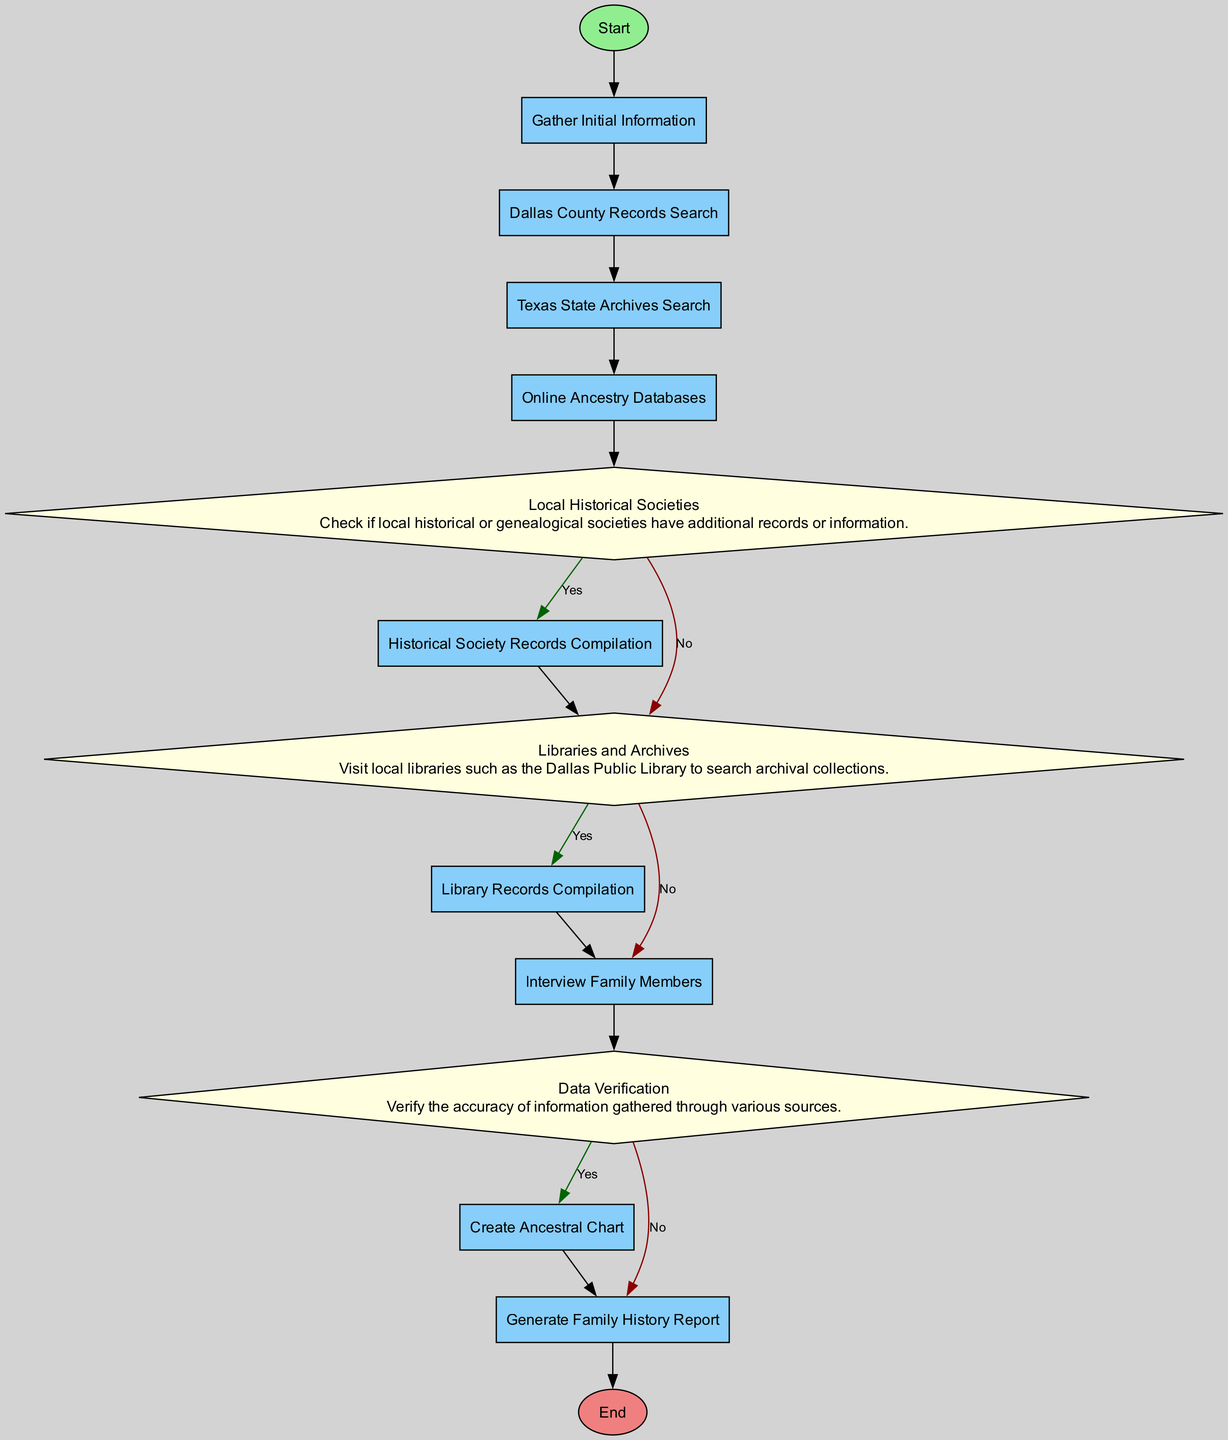What is the first step in the diagram? The diagram begins with the "Start" node, which signifies the initiation of the process. Therefore, the first step is simply to start the process.
Answer: Start How many decision nodes are present in the diagram? By reviewing the process flow, there are two decision nodes labeled "Local Historical Societies" and "Libraries and Archives." Thus, the total count of decision nodes is two.
Answer: 2 What follows the "Gather Initial Information" step? After the "Gather Initial Information," the next process in the flow is "Dallas County Records Search." This indicates a direct progression from gathering initial information to searching county records.
Answer: Dallas County Records Search What type of node is "Data Verification"? "Data Verification" is classified as a Decision node in the flowchart. This type of node indicates a point in the process where a yes/no decision must be made based on the information gathered.
Answer: Decision What process occurs after "Local Historical Societies"? Following the "Local Historical Societies" decision node, the flowchart leads to the process "Historical Society Records Compilation." This shows that if local societies have information, the next step is to compile it.
Answer: Historical Society Records Compilation How many processes are there in the diagram? The diagram consists of several process nodes, including "Gather Initial Information," "Dallas County Records Search," "Texas State Archives Search," "Online Ancestry Databases," "Historical Society Records Compilation," "Library Records Compilation," "Interview Family Members," "Create Ancestral Chart," and "Generate Family History Report." Counting these gives a total of nine process nodes.
Answer: 9 What is the last step before the "End" node? The final step before reaching the "End" node is the "Generate Family History Report." This indicates that all previous processes culminate in creating this report, leading to the conclusion of the flow.
Answer: Generate Family History Report Which two nodes directly lead to "Library Records Compilation"? The "Libraries and Archives" decision node leads to two outcomes: if "Yes," it directs to "Library Records Compilation," while if "No," it does not. Therefore, the only connecting node is the "Libraries and Archives" decision before it continues to the next processes.
Answer: Libraries and Archives What information is verified during the "Data Verification" step? During the "Data Verification" step, the accuracy of information gathered from various sources is verified. This ensures that any family history compiled is based on accurate and credible sources.
Answer: Accuracy of information 